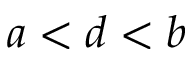Convert formula to latex. <formula><loc_0><loc_0><loc_500><loc_500>a < d < b</formula> 